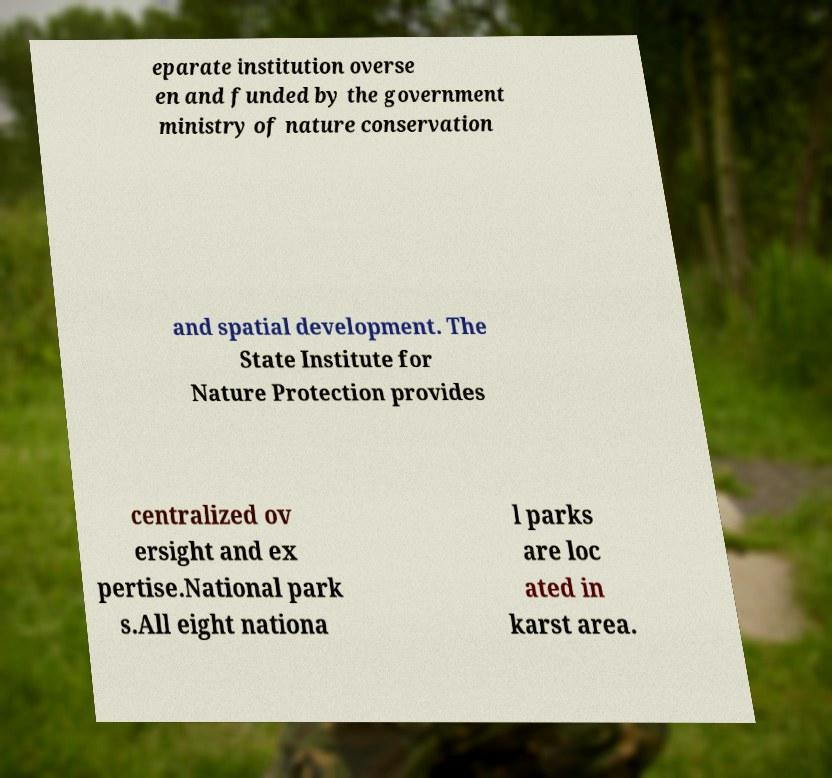For documentation purposes, I need the text within this image transcribed. Could you provide that? eparate institution overse en and funded by the government ministry of nature conservation and spatial development. The State Institute for Nature Protection provides centralized ov ersight and ex pertise.National park s.All eight nationa l parks are loc ated in karst area. 